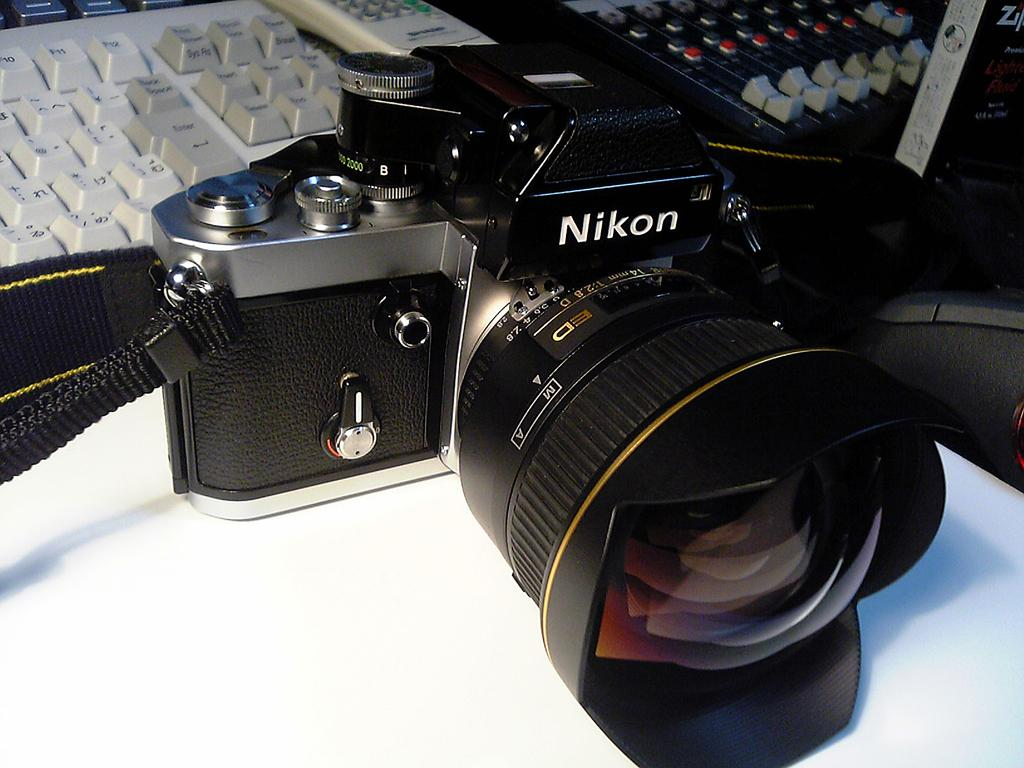What electronic device is located on the table in the image? There is a camera on the table in the image. What other electronic device is on the table? There is a keyboard on the table in the image. What object on the table might be used for controlling electronic devices? There is a remote on the table in the image. What can be seen on the right side of the image? There are other objects on the right side of the image. What type of reward is visible on the table in the image? There is no reward present in the image; it only shows a camera, keyboard, remote, and other objects on the table. What color is the lip of the person in the image? There is no person present in the image, so it is not possible to determine the color of their lip. 